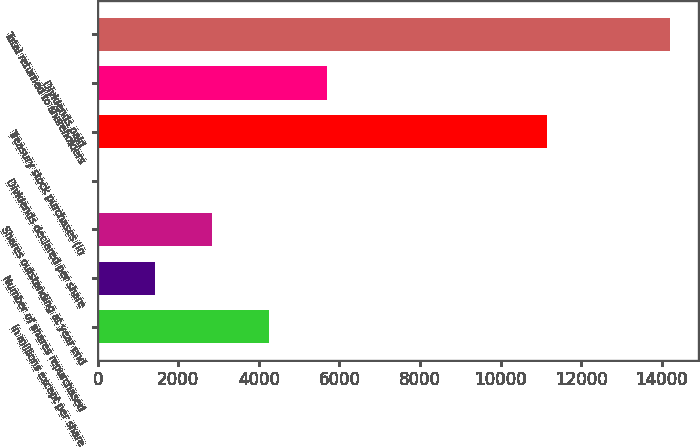Convert chart. <chart><loc_0><loc_0><loc_500><loc_500><bar_chart><fcel>In millions except per share<fcel>Number of shares repurchased<fcel>Shares outstanding at year end<fcel>Dividends declared per share<fcel>Treasury stock purchases (in<fcel>Dividends paid<fcel>Total returned to shareholders<nl><fcel>4262.53<fcel>1423.25<fcel>2842.89<fcel>3.61<fcel>11142<fcel>5682.17<fcel>14200<nl></chart> 